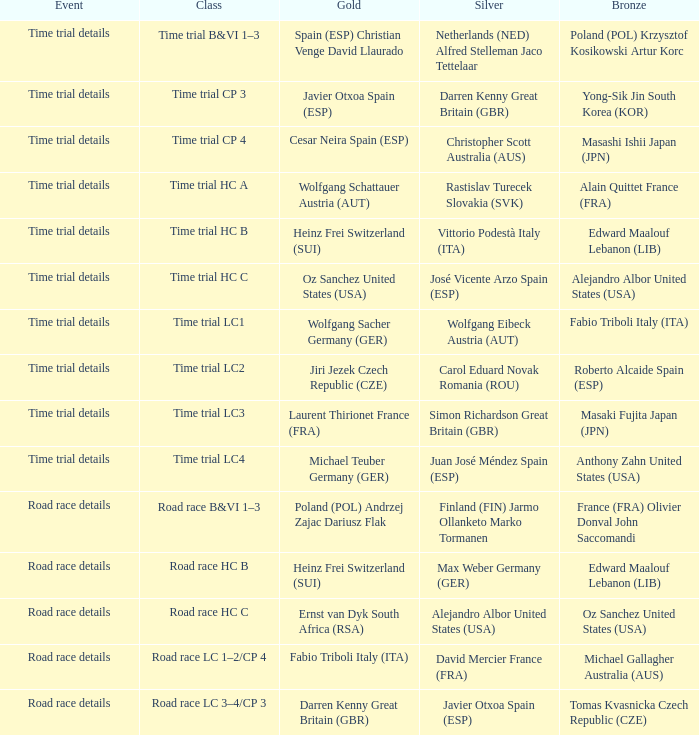Who received gold when the event is road race details and silver is max weber germany (ger)? Heinz Frei Switzerland (SUI). 